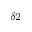Convert formula to latex. <formula><loc_0><loc_0><loc_500><loc_500>_ { \delta 2 }</formula> 